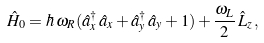Convert formula to latex. <formula><loc_0><loc_0><loc_500><loc_500>\hat { H } _ { 0 } = \hbar { \, } \omega _ { R } ( \hat { a } _ { x } ^ { \dagger } \, \hat { a } _ { x } + \hat { a } _ { y } ^ { \dagger } \, \hat { a } _ { y } + 1 ) + \frac { \omega _ { L } } { 2 } \, \hat { L } _ { z } \, ,</formula> 